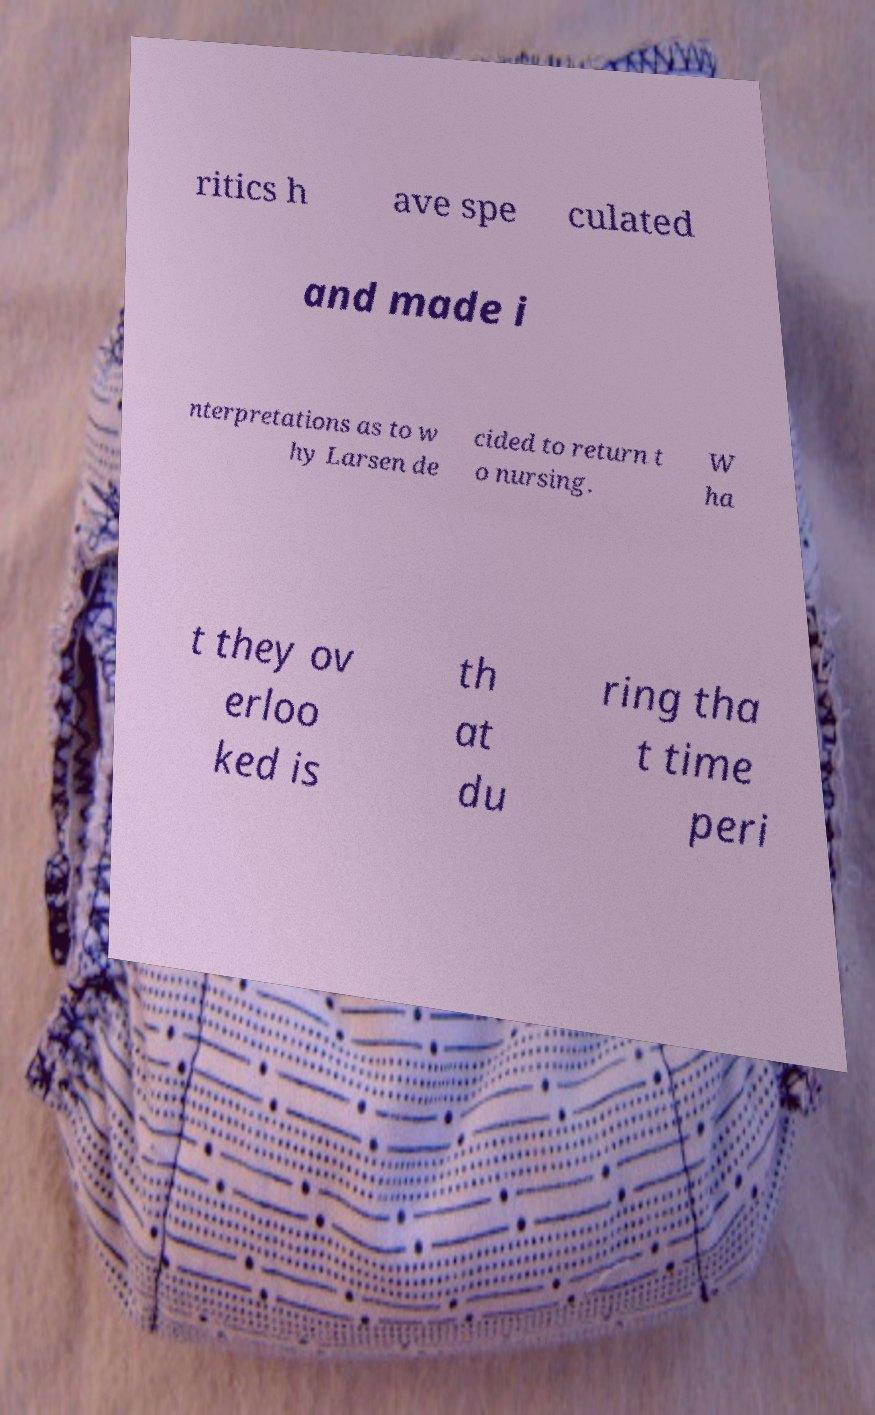Please identify and transcribe the text found in this image. ritics h ave spe culated and made i nterpretations as to w hy Larsen de cided to return t o nursing. W ha t they ov erloo ked is th at du ring tha t time peri 